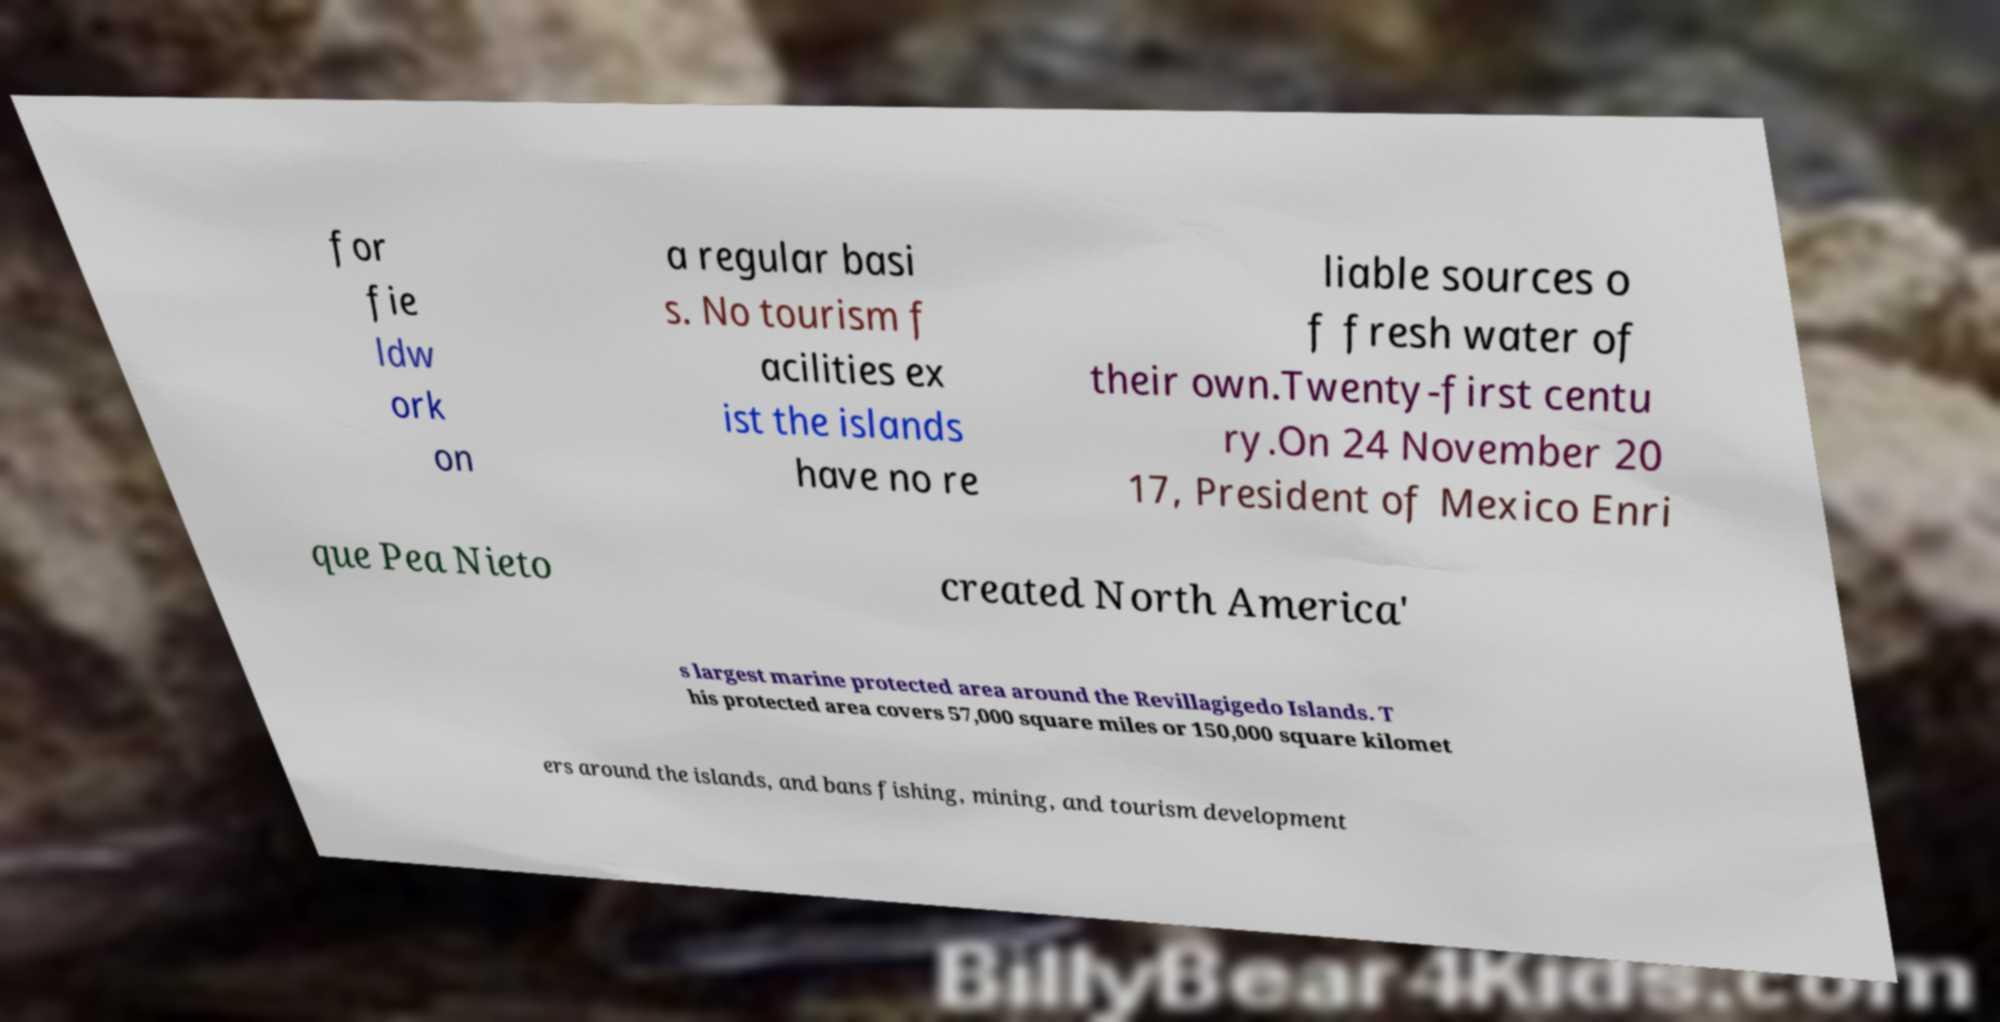Can you read and provide the text displayed in the image?This photo seems to have some interesting text. Can you extract and type it out for me? for fie ldw ork on a regular basi s. No tourism f acilities ex ist the islands have no re liable sources o f fresh water of their own.Twenty-first centu ry.On 24 November 20 17, President of Mexico Enri que Pea Nieto created North America' s largest marine protected area around the Revillagigedo Islands. T his protected area covers 57,000 square miles or 150,000 square kilomet ers around the islands, and bans fishing, mining, and tourism development 